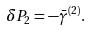Convert formula to latex. <formula><loc_0><loc_0><loc_500><loc_500>\delta P _ { 2 } = - \bar { \gamma } ^ { ( 2 ) } .</formula> 